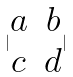<formula> <loc_0><loc_0><loc_500><loc_500>| \begin{matrix} a & b \\ c & d \end{matrix} |</formula> 